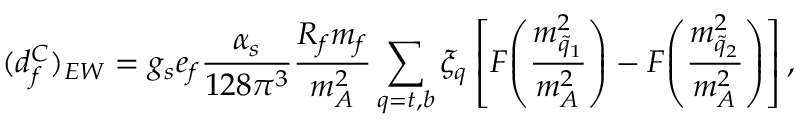Convert formula to latex. <formula><loc_0><loc_0><loc_500><loc_500>( d _ { f } ^ { C } ) _ { E W } = g _ { s } e _ { f } { \frac { \alpha _ { s } } { 1 2 8 \pi ^ { 3 } } } { \frac { R _ { f } m _ { f } } { m _ { A } ^ { 2 } } } \sum _ { q = t , b } \xi _ { q } \left [ F \, \left ( { \frac { m _ { \tilde { q } _ { 1 } } ^ { 2 } } { m _ { A } ^ { 2 } } } \right ) - F \, \left ( { \frac { m _ { \tilde { q } _ { 2 } } ^ { 2 } } { m _ { A } ^ { 2 } } } \right ) \right ] ,</formula> 